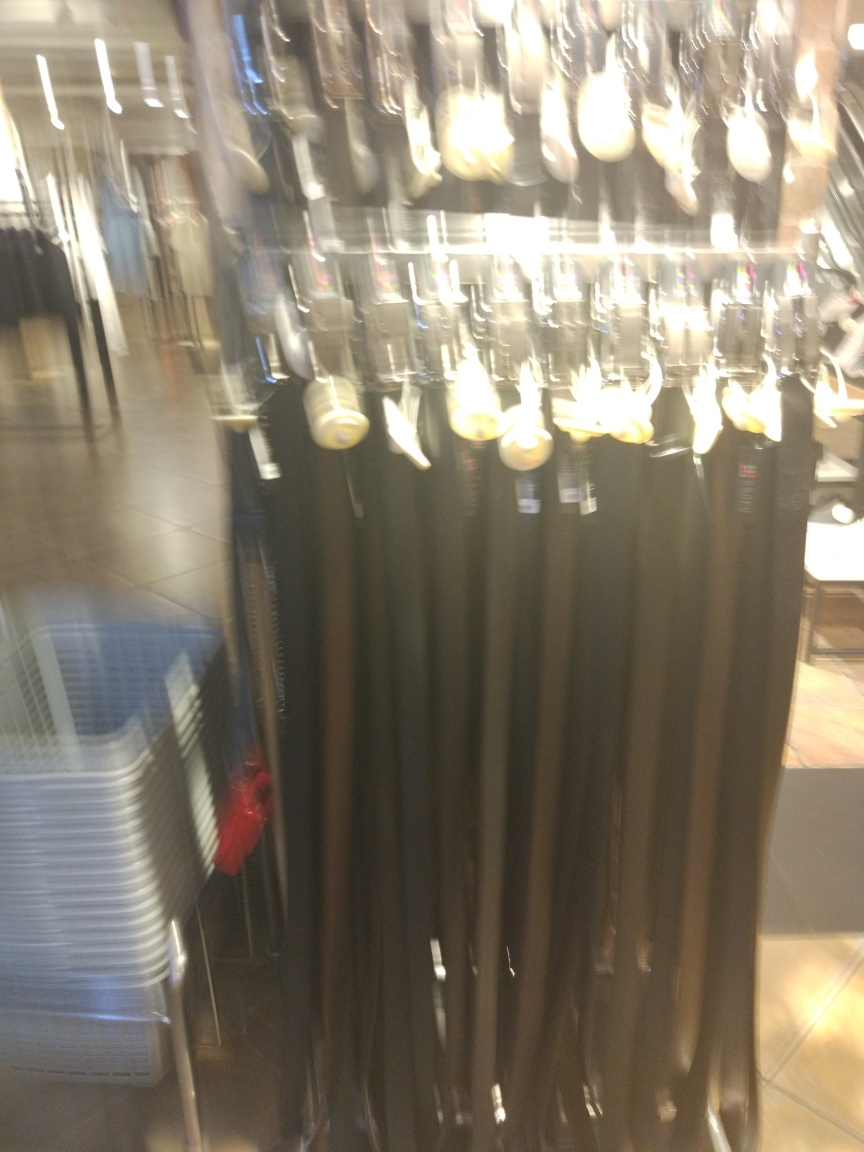What tips would you give to take a better picture of this display? To improve the picture quality, stabilize the camera or phone to prevent motion blur, use adequate lighting, and possibly a higher shutter speed. Also, ensure a clean composition by focusing on the subject and removing distractions from the frame. Could a better photo affect sales in an online store? Absolutely. High-quality, clear photos can significantly impact online sales by accurately representing the product, which helps build customer trust and can lead to higher conversion rates. 